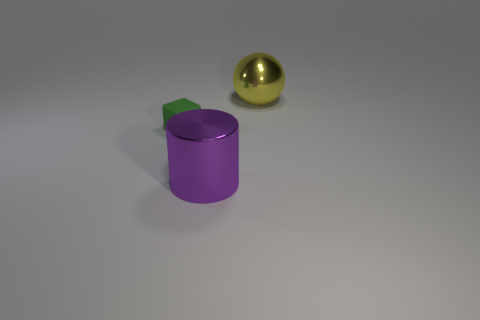Is there anything else that is the same size as the green thing?
Provide a succinct answer. No. There is a purple object that is the same size as the yellow ball; what is its material?
Provide a succinct answer. Metal. What number of large objects are either purple metallic cylinders or yellow metal objects?
Make the answer very short. 2. How many things are on the right side of the large purple metallic thing and in front of the large shiny sphere?
Offer a terse response. 0. There is a large thing that is the same material as the large ball; what shape is it?
Your answer should be compact. Cylinder. Do the purple metallic thing and the block have the same size?
Ensure brevity in your answer.  No. Are the big thing that is behind the tiny green block and the cylinder made of the same material?
Your response must be concise. Yes. Is there anything else that has the same material as the large purple cylinder?
Provide a short and direct response. Yes. There is a large shiny object left of the large object behind the green rubber cube; what number of yellow spheres are in front of it?
Your answer should be compact. 0. Do the big shiny object in front of the shiny sphere and the big yellow metal object have the same shape?
Provide a short and direct response. No. 